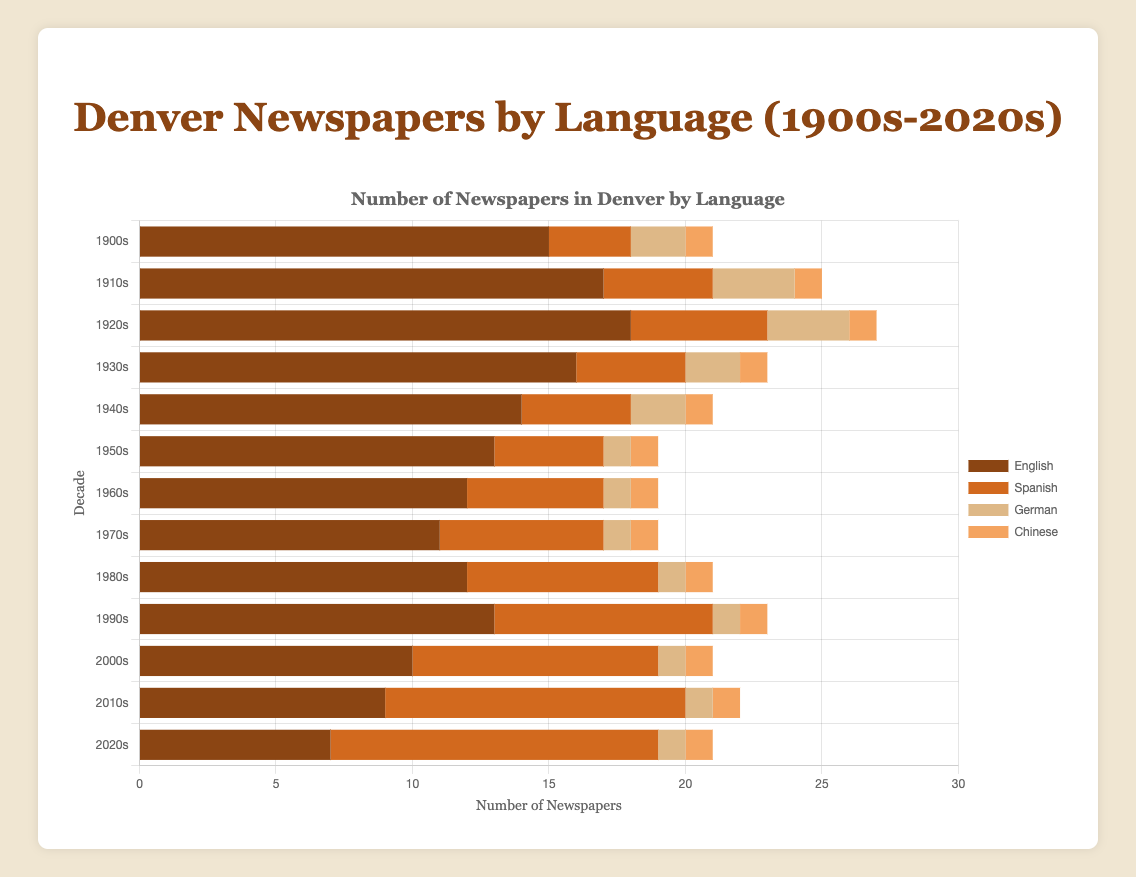Which language saw the highest number of newspapers in the 1920s? By looking at the bars corresponding to each language in the 1920s, the English bar is the highest, indicating the highest number of newspapers.
Answer: English How many more Spanish newspapers were there in the 2020s compared to the 1910s? Subtract the number of Spanish newspapers in the 1910s from the number in the 2020s (12 - 4 = 8).
Answer: 8 What is the total number of German and Chinese newspapers in the 2000s? Add the number of German newspapers to the number of Chinese newspapers in the 2000s (1 + 1 = 2).
Answer: 2 Which decade had the lowest total number of newspapers, and what was that number? Compare all the total values for each decade. The 1950s and 1960s both had the lowest total number of newspapers, which is 19.
Answer: 1950s and 1960s, 19 Did the number of English newspapers increase or decrease from the 1960s to the 1970s, and by how much? Compare the number of English newspapers in the 1960s and 1970s. The number in the 1960s was 12, and in the 1970s, it was 11, indicating a decrease of 1.
Answer: Decrease by 1 What is the average number of Spanish newspapers per decade from the 1900s to the 2020s? Sum the number of Spanish newspapers from each decade (3 + 4 + 5 + 4 + 4 + 4 + 5 + 6 + 7 + 8 + 9 + 11 + 12 = 82). Then, divide by the number of decades (13). 82 ÷ 13 ≈ 6.31.
Answer: About 6.31 Between which decades did the number of English newspapers see the largest decrease? Compare the decreases in English newspapers between consecutive decades. The largest decrease happens from the 1930s to the 1940s (16 - 14 = 2). From the 2000s to the 2010s (10 - 9 = 1) and from the 2010s to the 2020s (9 - 7 = 2) both have a decrease of 2. Further analysis shows the largest decrease in the number of newspapers happens from the 1900s to the 1910s (15 - 17 = -2).
Answer: From the 2000s to the 2010s, 2 In which decade did the total number of newspapers peak, and what was the count? By comparing the total number of newspapers in each decade, the 1920s saw the highest total number of newspapers with a count of 27.
Answer: 1920s, 27 How many more Chinese newspapers were there in the entire period (1900s-2020s) compared to German newspapers in the 1950s? Sum the numbers of Chinese newspapers for all decades, which is 13 (1 newspaper per decade). The number of German newspapers in the 1950s is 1. The increase in Chinese newspapers is 13 - 1.
Answer: 12 